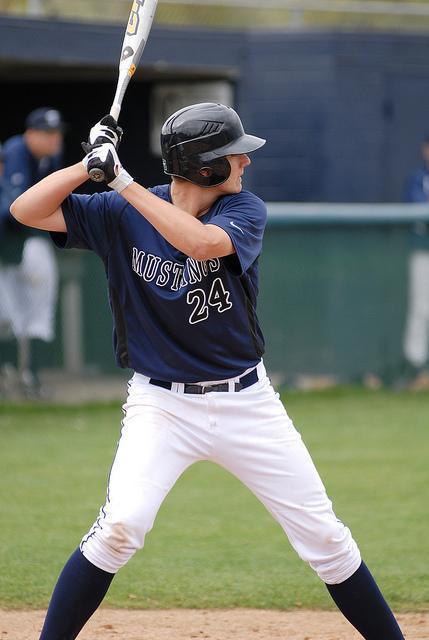How many people can you see?
Give a very brief answer. 2. 